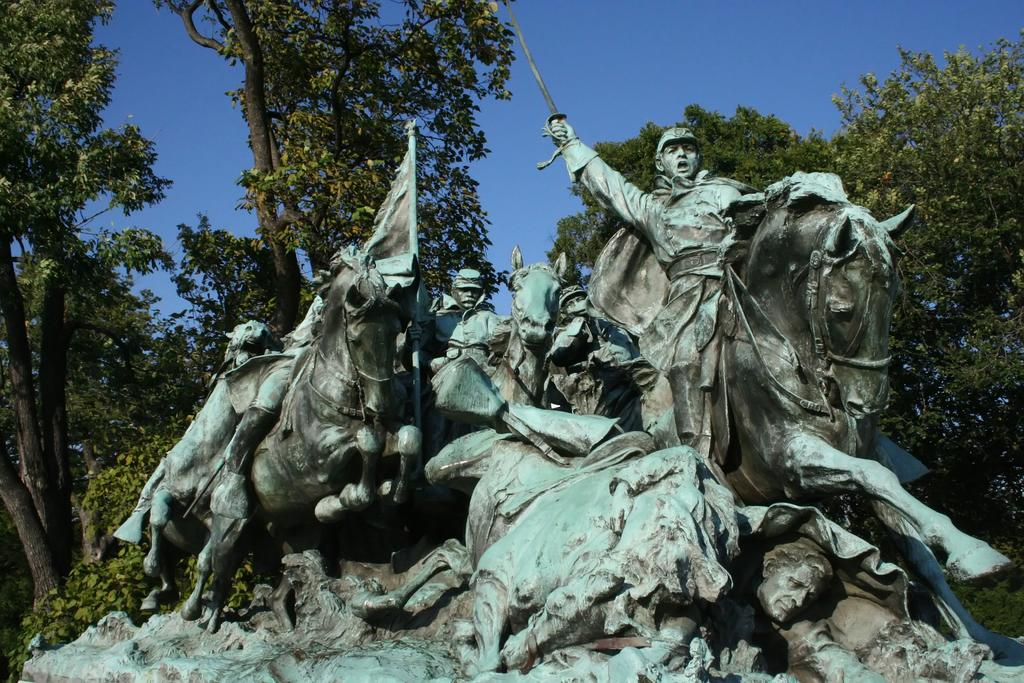What is the main subject in the center of the image? There is a statue in the center of the image. What can be seen in the background of the image? There are trees and the sky visible in the background of the image. What type of glass is being used by the statue in the image? There is no glass present in the image, as it features a statue and natural elements in the background. 